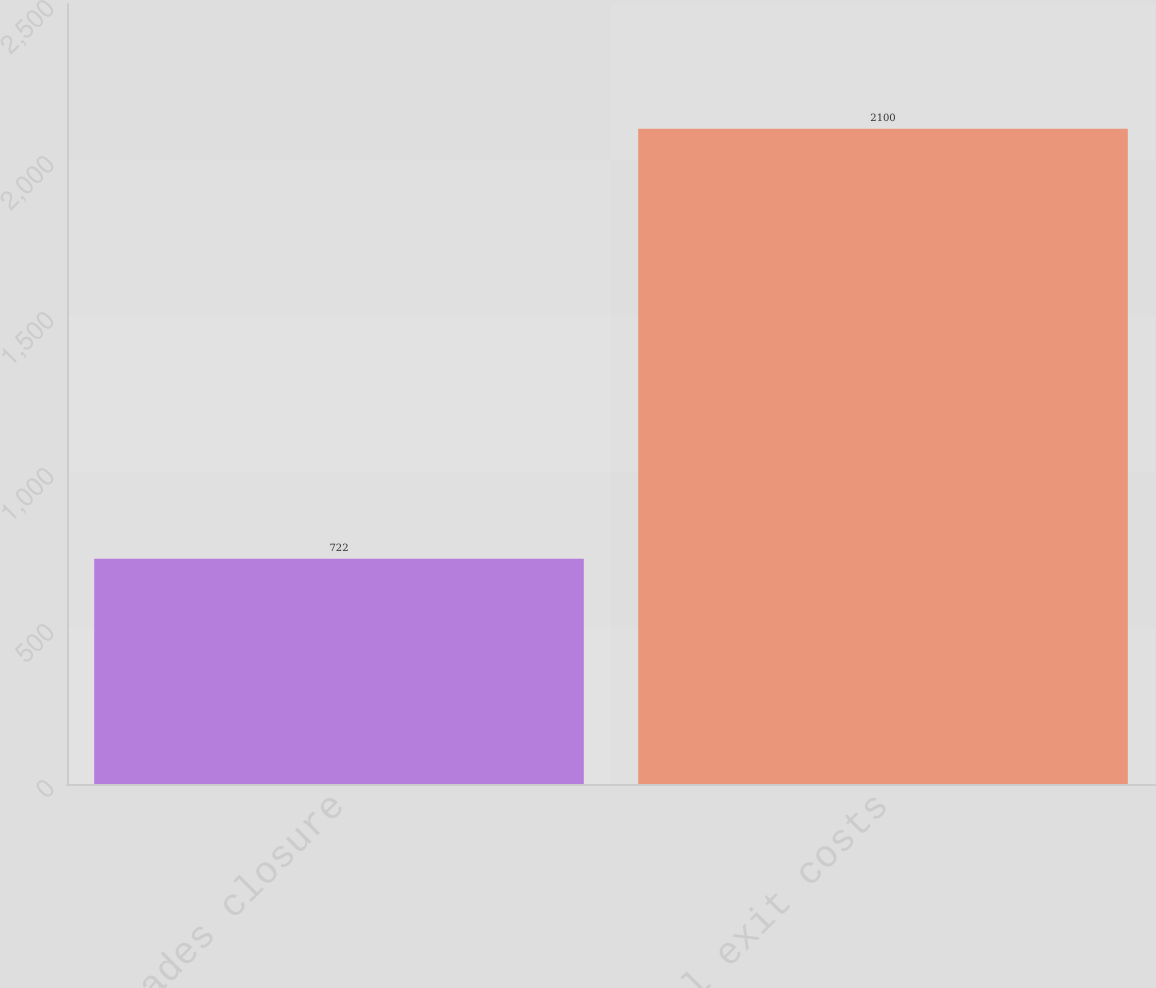<chart> <loc_0><loc_0><loc_500><loc_500><bar_chart><fcel>Varades closure<fcel>Total exit costs<nl><fcel>722<fcel>2100<nl></chart> 